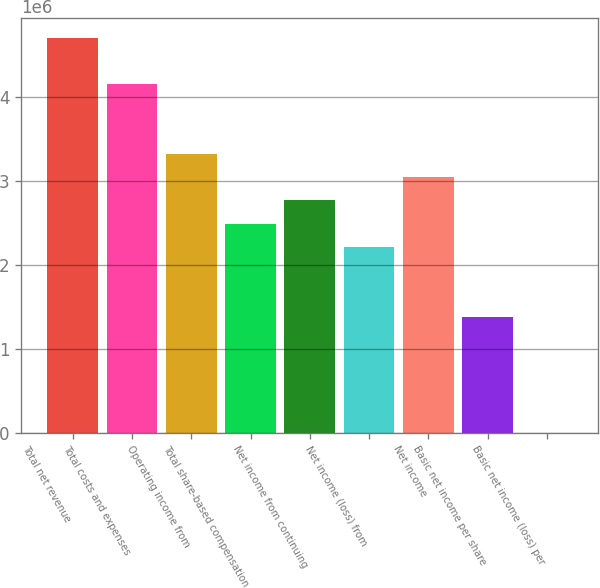Convert chart to OTSL. <chart><loc_0><loc_0><loc_500><loc_500><bar_chart><fcel>Total net revenue<fcel>Total costs and expenses<fcel>Operating income from<fcel>Total share-based compensation<fcel>Net income from continuing<fcel>Net income (loss) from<fcel>Net income<fcel>Basic net income per share<fcel>Basic net income (loss) per<nl><fcel>4.70905e+06<fcel>4.15504e+06<fcel>3.32403e+06<fcel>2.49302e+06<fcel>2.77003e+06<fcel>2.21602e+06<fcel>3.04703e+06<fcel>1.38501e+06<fcel>0.1<nl></chart> 